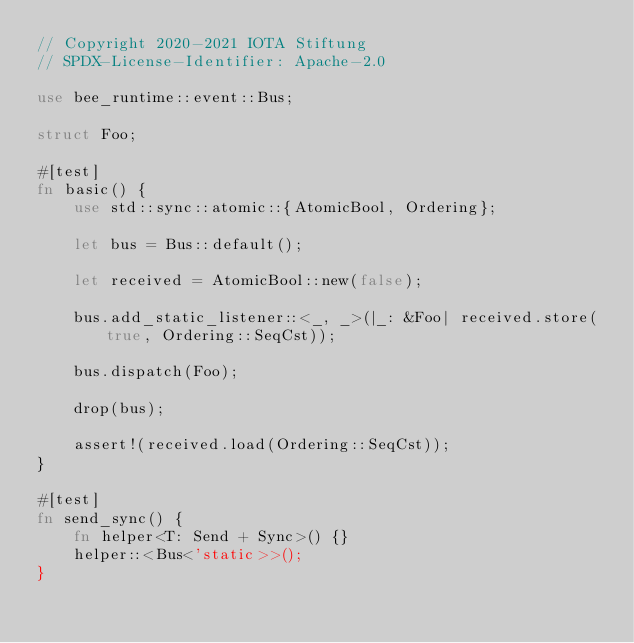Convert code to text. <code><loc_0><loc_0><loc_500><loc_500><_Rust_>// Copyright 2020-2021 IOTA Stiftung
// SPDX-License-Identifier: Apache-2.0

use bee_runtime::event::Bus;

struct Foo;

#[test]
fn basic() {
    use std::sync::atomic::{AtomicBool, Ordering};

    let bus = Bus::default();

    let received = AtomicBool::new(false);

    bus.add_static_listener::<_, _>(|_: &Foo| received.store(true, Ordering::SeqCst));

    bus.dispatch(Foo);

    drop(bus);

    assert!(received.load(Ordering::SeqCst));
}

#[test]
fn send_sync() {
    fn helper<T: Send + Sync>() {}
    helper::<Bus<'static>>();
}
</code> 